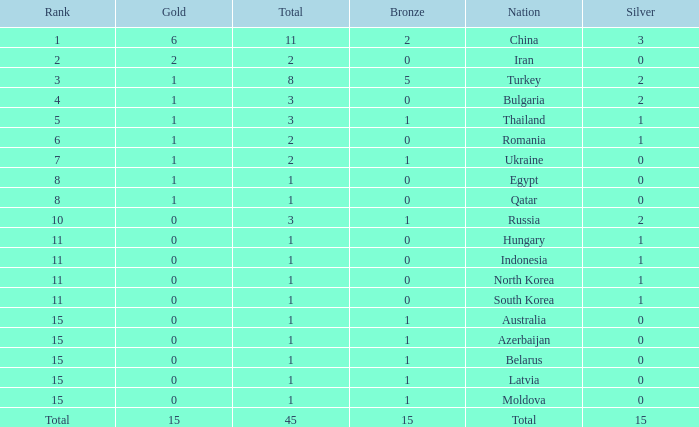What is the sum of the bronze medals of the nation with less than 0 silvers? None. 